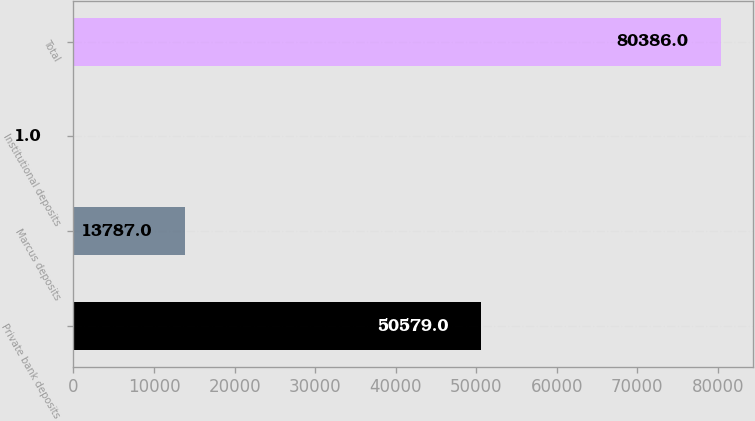Convert chart to OTSL. <chart><loc_0><loc_0><loc_500><loc_500><bar_chart><fcel>Private bank deposits<fcel>Marcus deposits<fcel>Institutional deposits<fcel>Total<nl><fcel>50579<fcel>13787<fcel>1<fcel>80386<nl></chart> 